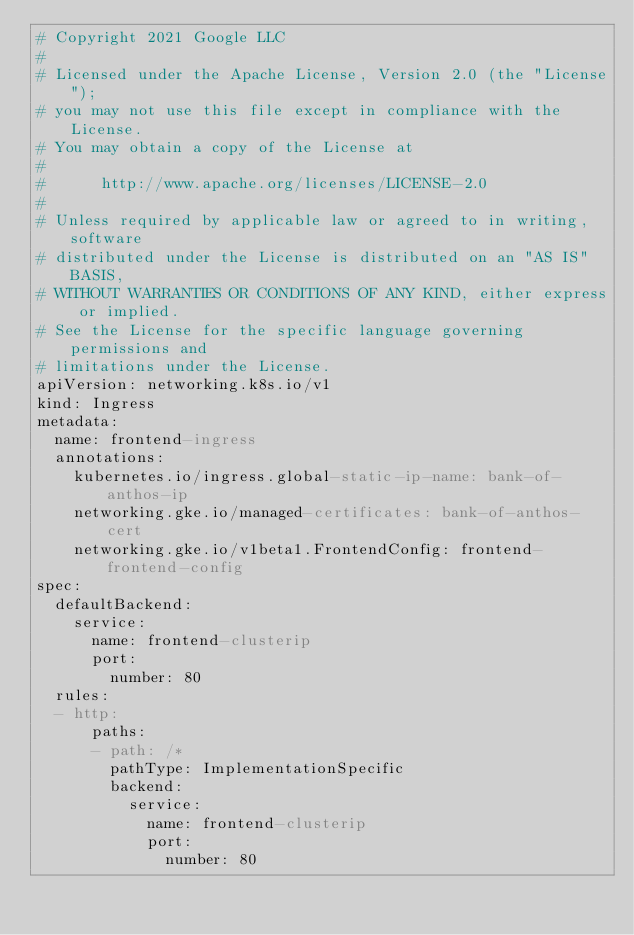Convert code to text. <code><loc_0><loc_0><loc_500><loc_500><_YAML_># Copyright 2021 Google LLC
#
# Licensed under the Apache License, Version 2.0 (the "License");
# you may not use this file except in compliance with the License.
# You may obtain a copy of the License at
#
#      http://www.apache.org/licenses/LICENSE-2.0
#
# Unless required by applicable law or agreed to in writing, software
# distributed under the License is distributed on an "AS IS" BASIS,
# WITHOUT WARRANTIES OR CONDITIONS OF ANY KIND, either express or implied.
# See the License for the specific language governing permissions and
# limitations under the License.
apiVersion: networking.k8s.io/v1
kind: Ingress
metadata:
  name: frontend-ingress
  annotations:
    kubernetes.io/ingress.global-static-ip-name: bank-of-anthos-ip
    networking.gke.io/managed-certificates: bank-of-anthos-cert
    networking.gke.io/v1beta1.FrontendConfig: frontend-frontend-config
spec:
  defaultBackend:
    service:
      name: frontend-clusterip
      port:
        number: 80
  rules:
  - http:
      paths:
      - path: /*
        pathType: ImplementationSpecific
        backend:
          service:
            name: frontend-clusterip
            port:
              number: 80
</code> 